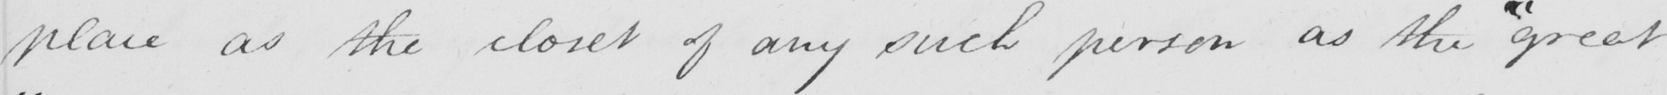Please transcribe the handwritten text in this image. place as the closet of any such person as the  " great 